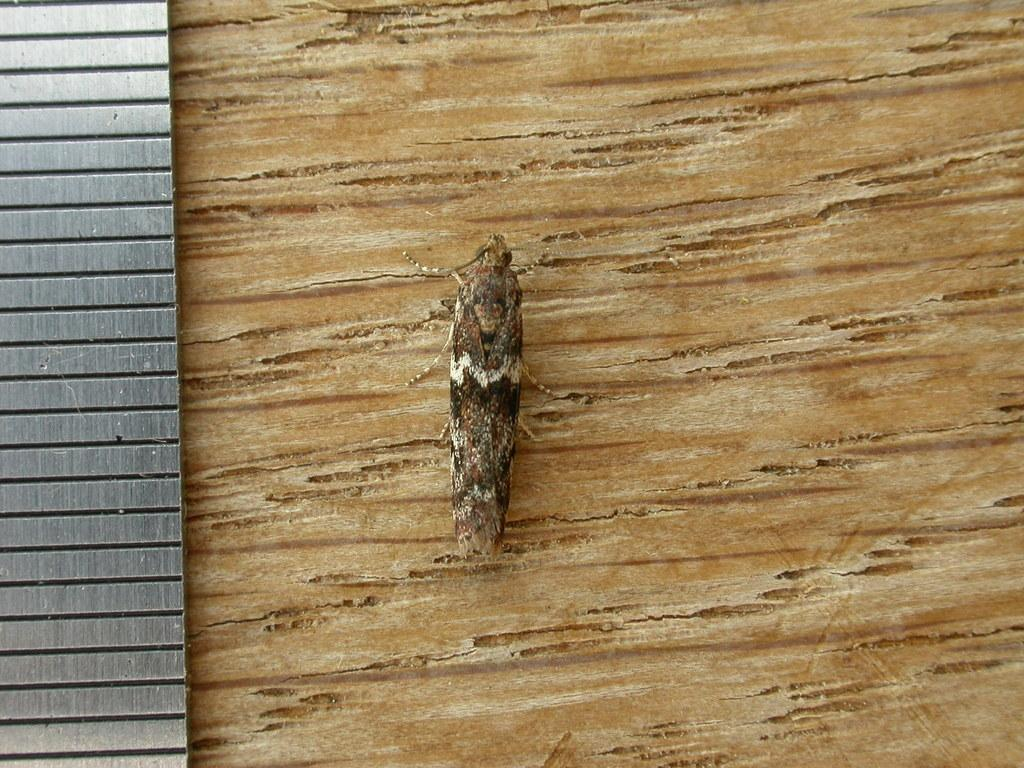What type of creature can be seen in the image? There is an insect in the image. Where is the insect located? The insect is on an object. What is present on the left side of the object? There is a steel item on the left side of the object. What type of zebra can be seen sitting on the cushion in the image? There is no zebra or cushion present in the image; it features an insect on an object with a steel item on the left side. 